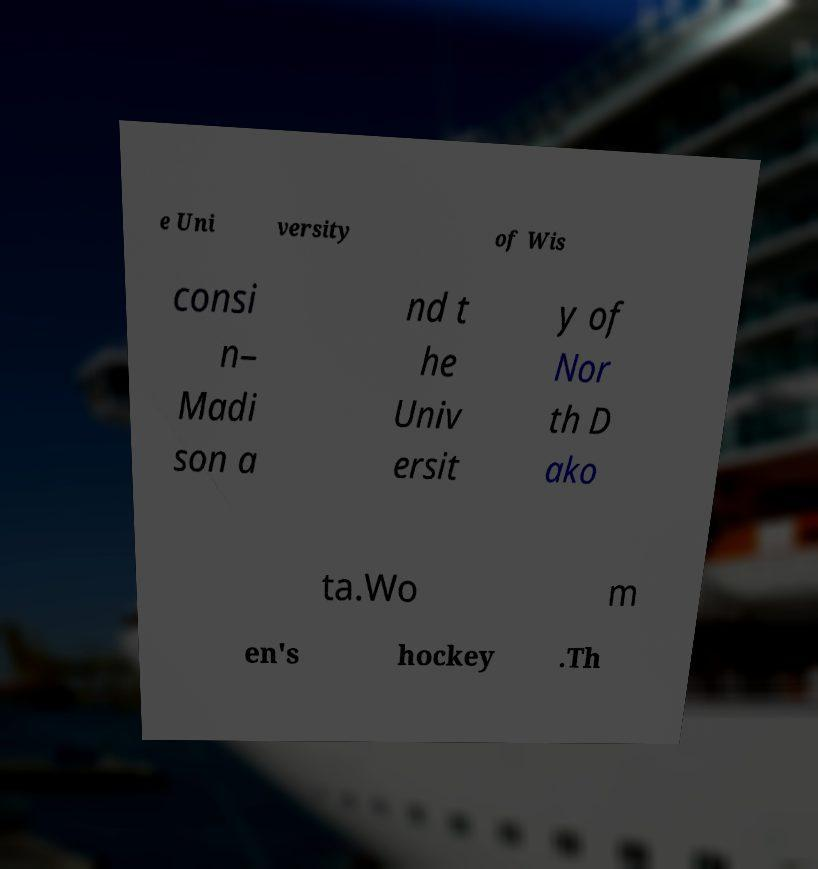Could you assist in decoding the text presented in this image and type it out clearly? e Uni versity of Wis consi n– Madi son a nd t he Univ ersit y of Nor th D ako ta.Wo m en's hockey .Th 